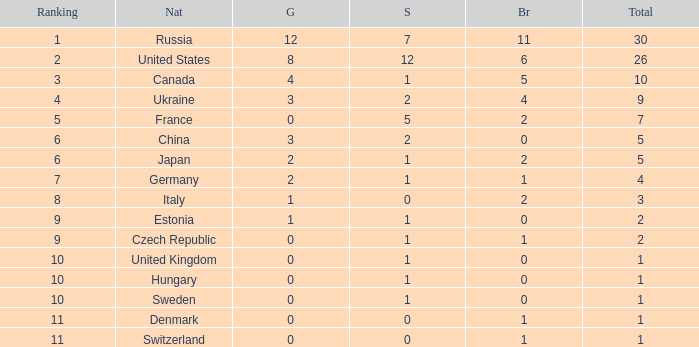Which silver has a Gold smaller than 12, a Rank smaller than 5, and a Bronze of 5? 1.0. 